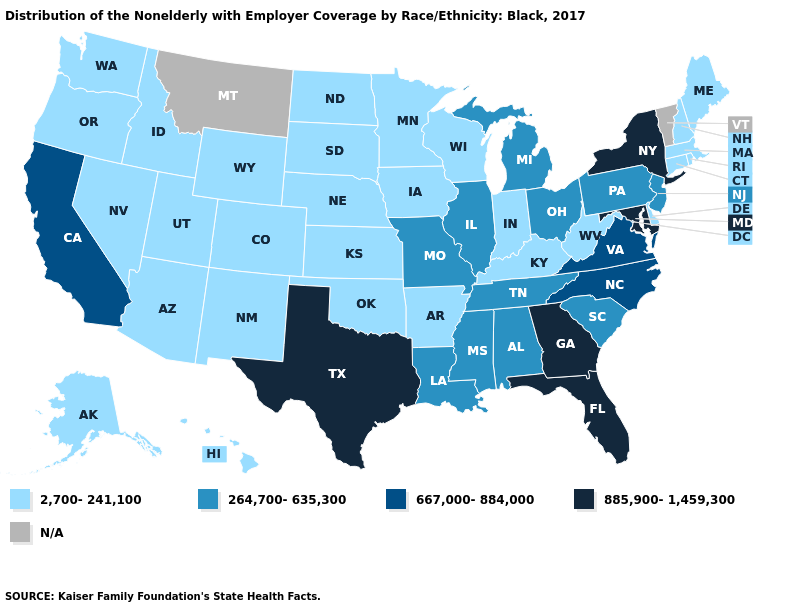Which states have the highest value in the USA?
Concise answer only. Florida, Georgia, Maryland, New York, Texas. What is the value of Pennsylvania?
Answer briefly. 264,700-635,300. What is the value of West Virginia?
Answer briefly. 2,700-241,100. Which states have the lowest value in the West?
Give a very brief answer. Alaska, Arizona, Colorado, Hawaii, Idaho, Nevada, New Mexico, Oregon, Utah, Washington, Wyoming. What is the highest value in the USA?
Give a very brief answer. 885,900-1,459,300. Name the states that have a value in the range 264,700-635,300?
Short answer required. Alabama, Illinois, Louisiana, Michigan, Mississippi, Missouri, New Jersey, Ohio, Pennsylvania, South Carolina, Tennessee. Does the map have missing data?
Short answer required. Yes. Among the states that border Massachusetts , which have the highest value?
Write a very short answer. New York. Which states have the highest value in the USA?
Keep it brief. Florida, Georgia, Maryland, New York, Texas. Name the states that have a value in the range 667,000-884,000?
Give a very brief answer. California, North Carolina, Virginia. What is the lowest value in the MidWest?
Concise answer only. 2,700-241,100. Does Georgia have the highest value in the USA?
Write a very short answer. Yes. 